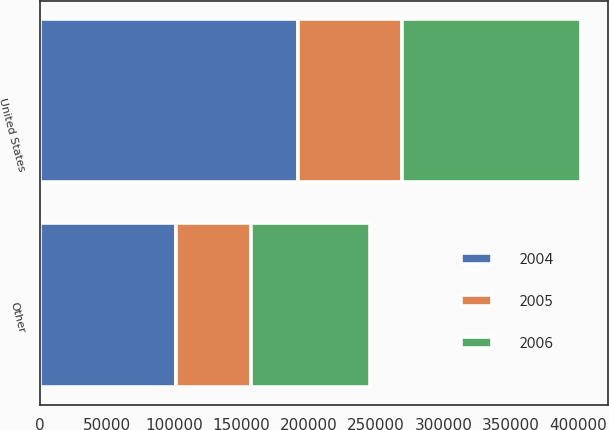Convert chart to OTSL. <chart><loc_0><loc_0><loc_500><loc_500><stacked_bar_chart><ecel><fcel>United States<fcel>Other<nl><fcel>2004<fcel>191649<fcel>101223<nl><fcel>2006<fcel>132680<fcel>87887<nl><fcel>2005<fcel>77636<fcel>56080<nl></chart> 